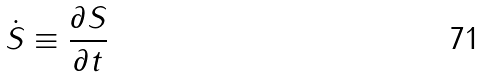Convert formula to latex. <formula><loc_0><loc_0><loc_500><loc_500>\dot { S } \equiv \frac { \partial S } { \partial t }</formula> 